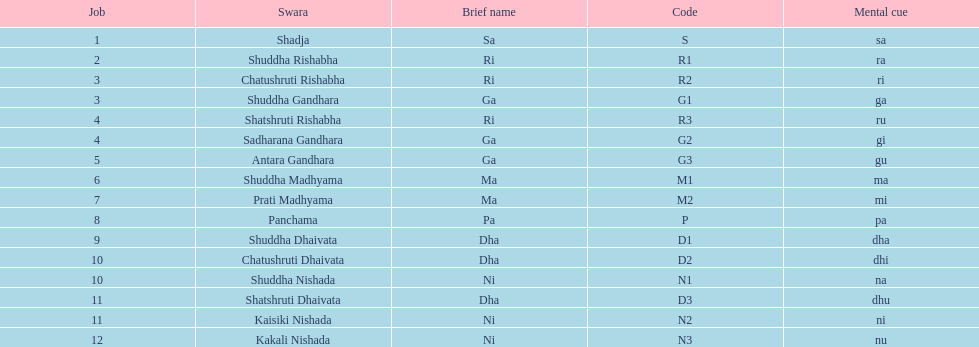What swara is above shatshruti dhaivata? Shuddha Nishada. 